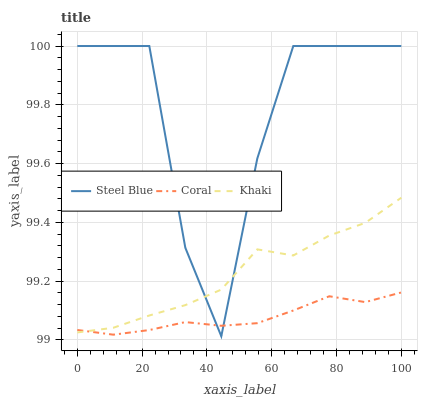Does Coral have the minimum area under the curve?
Answer yes or no. Yes. Does Steel Blue have the maximum area under the curve?
Answer yes or no. Yes. Does Khaki have the minimum area under the curve?
Answer yes or no. No. Does Khaki have the maximum area under the curve?
Answer yes or no. No. Is Coral the smoothest?
Answer yes or no. Yes. Is Steel Blue the roughest?
Answer yes or no. Yes. Is Khaki the smoothest?
Answer yes or no. No. Is Khaki the roughest?
Answer yes or no. No. Does Steel Blue have the lowest value?
Answer yes or no. Yes. Does Khaki have the lowest value?
Answer yes or no. No. Does Steel Blue have the highest value?
Answer yes or no. Yes. Does Khaki have the highest value?
Answer yes or no. No. Does Steel Blue intersect Coral?
Answer yes or no. Yes. Is Steel Blue less than Coral?
Answer yes or no. No. Is Steel Blue greater than Coral?
Answer yes or no. No. 